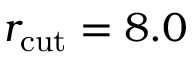<formula> <loc_0><loc_0><loc_500><loc_500>r _ { c u t } = 8 . 0</formula> 